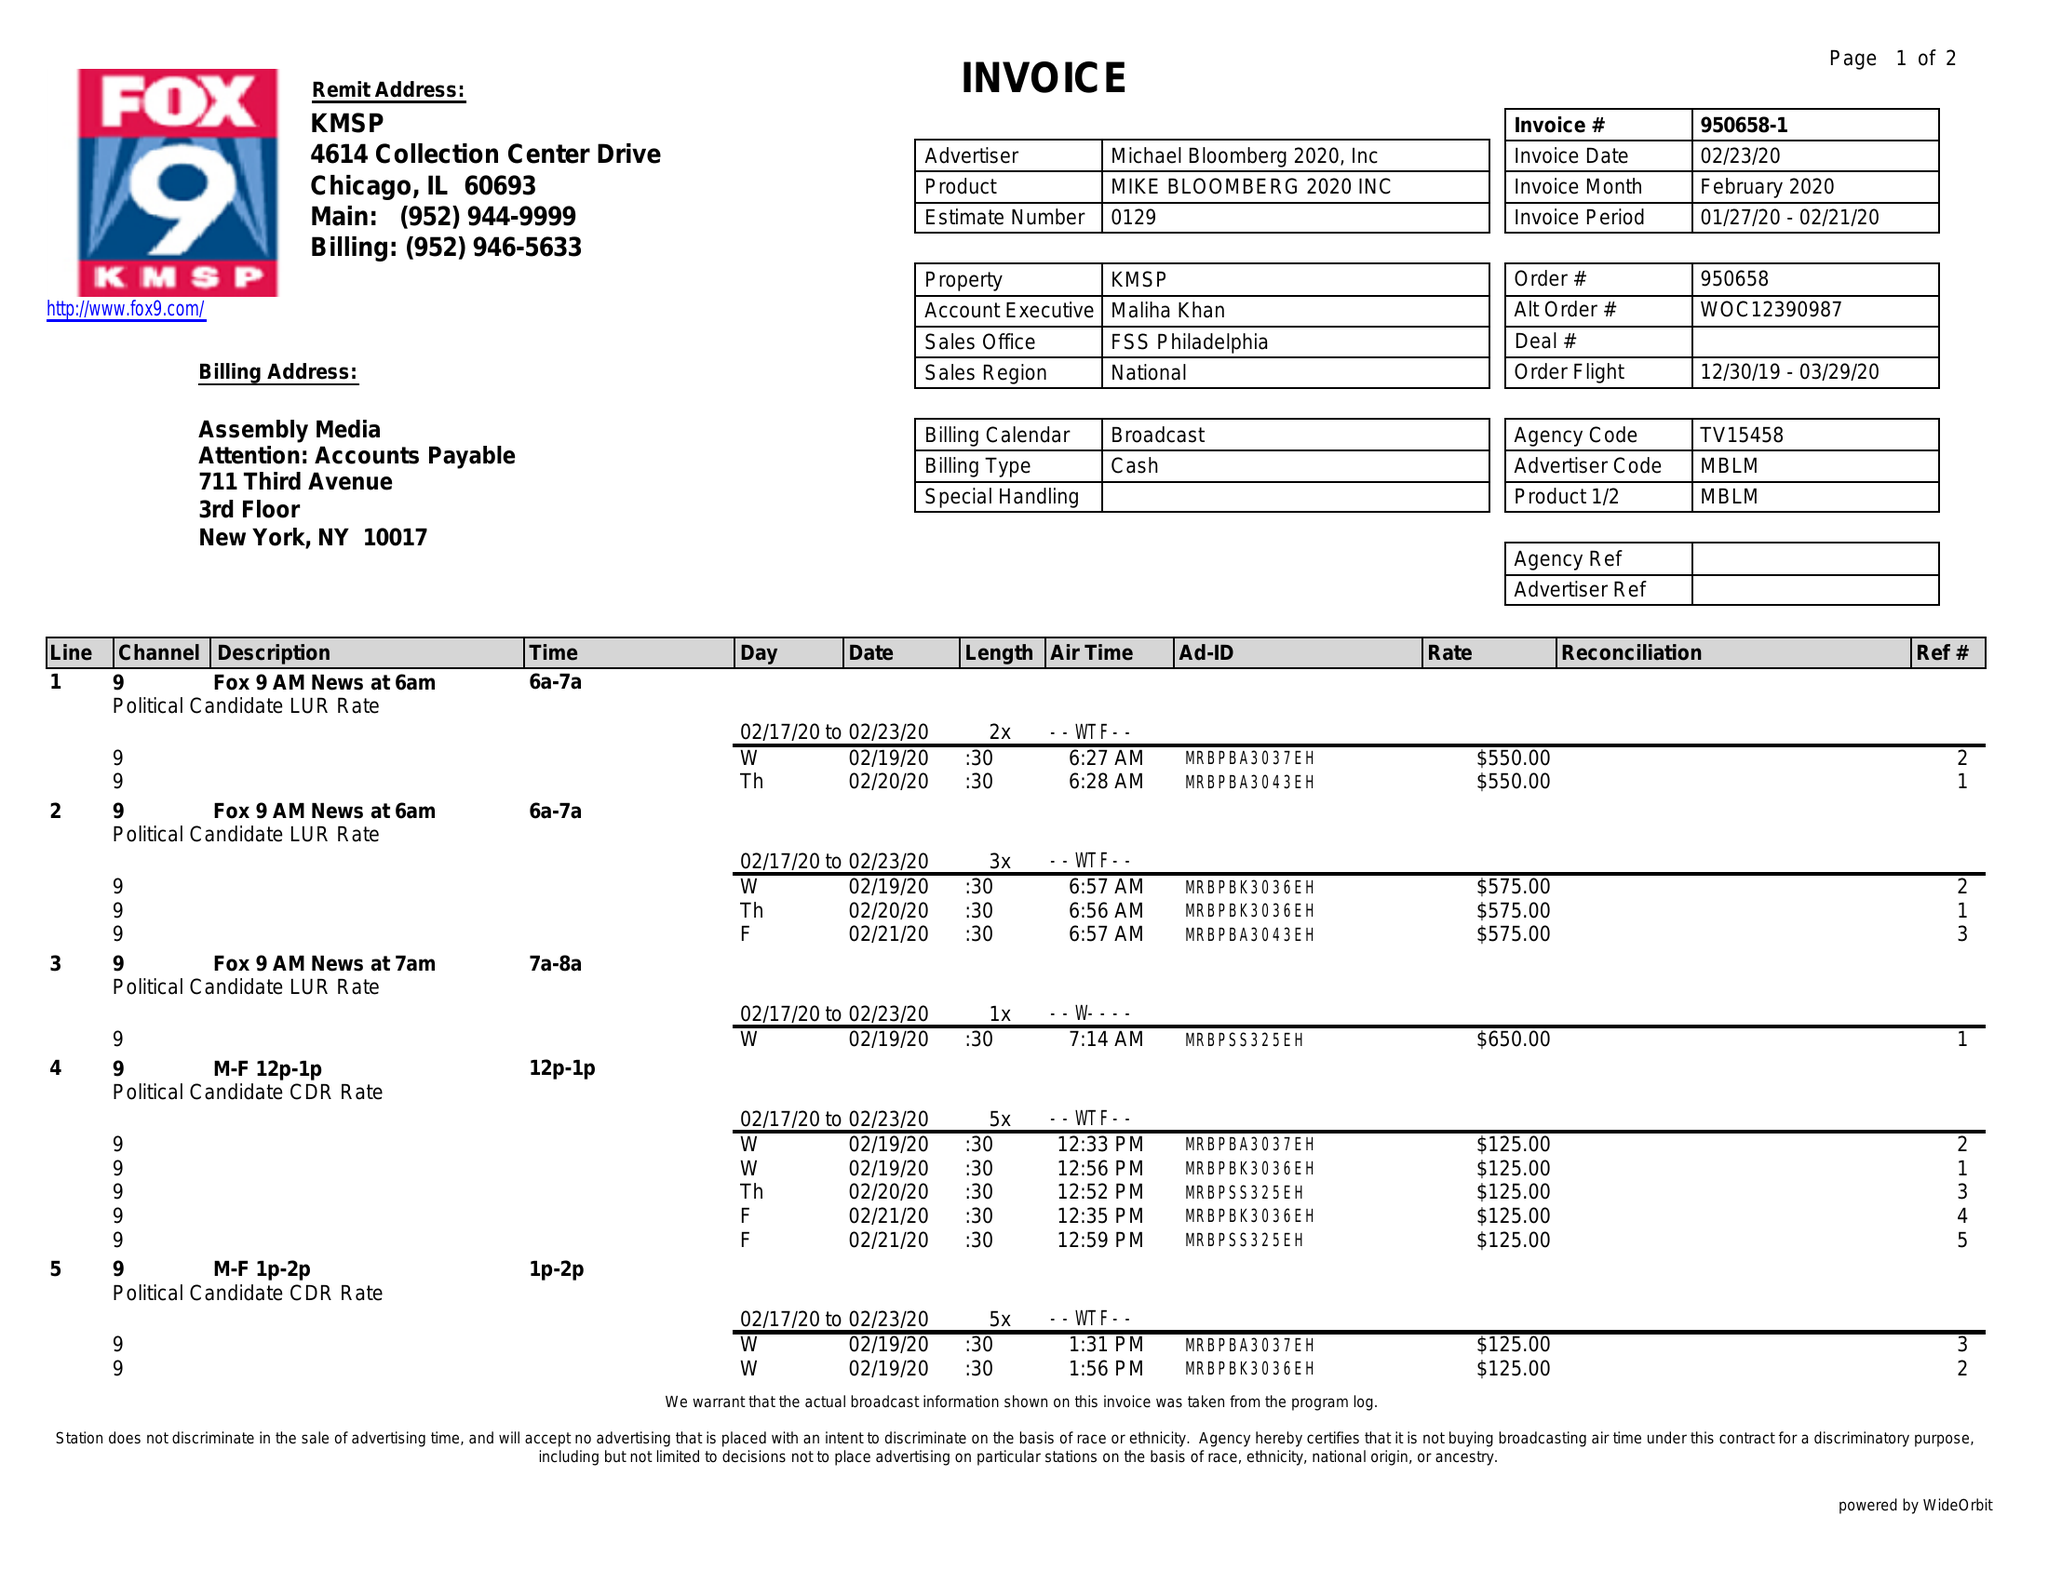What is the value for the flight_from?
Answer the question using a single word or phrase. 12/30/19 